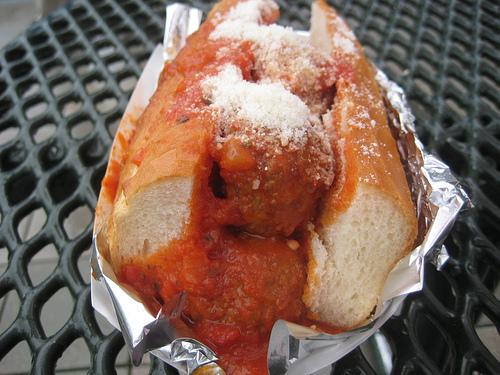Is the hoagie on a plate?
Keep it brief. No. What type of hoagie is this?
Keep it brief. Meatball. What is the red liquid called?
Give a very brief answer. Sauce. 